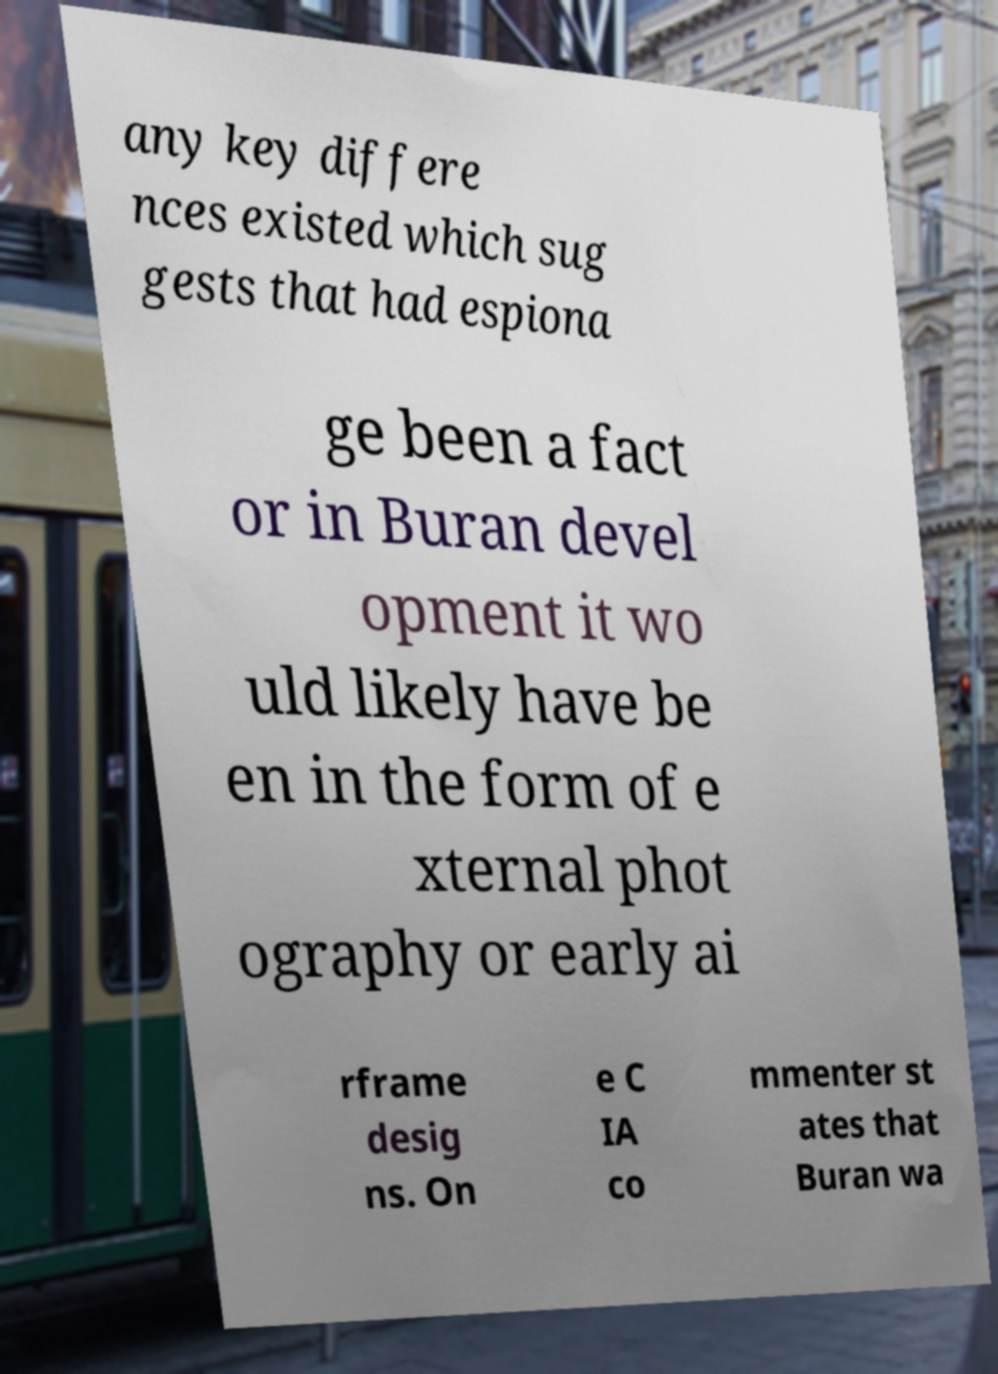What messages or text are displayed in this image? I need them in a readable, typed format. any key differe nces existed which sug gests that had espiona ge been a fact or in Buran devel opment it wo uld likely have be en in the form of e xternal phot ography or early ai rframe desig ns. On e C IA co mmenter st ates that Buran wa 